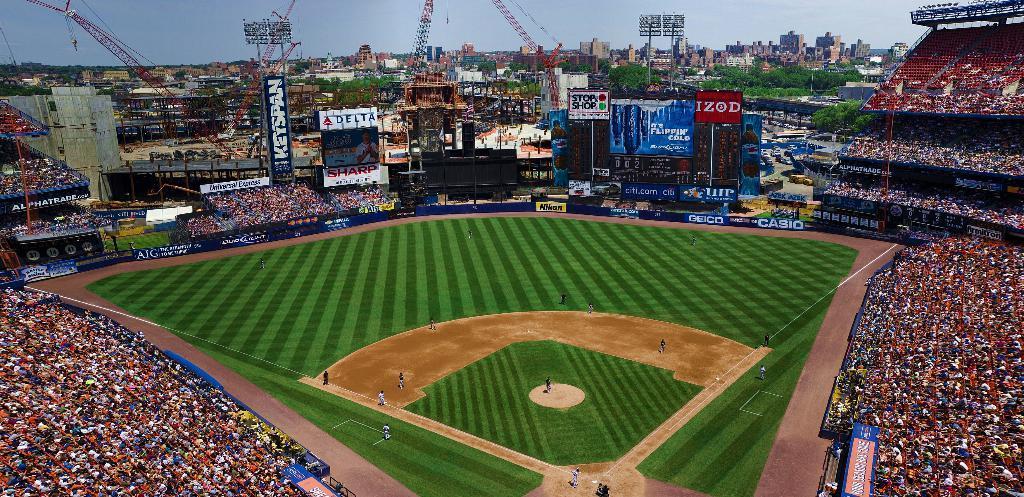In one or two sentences, can you explain what this image depicts? This is a stadium. Here I can see a crowd of people sitting facing towards the ground. There are few people playing a game in the ground. In the background there are many buildings, trees and also I can see few cranes. Around the playing ground there are many boards on which I can see the text. At the top of the image I can see in the sky. 